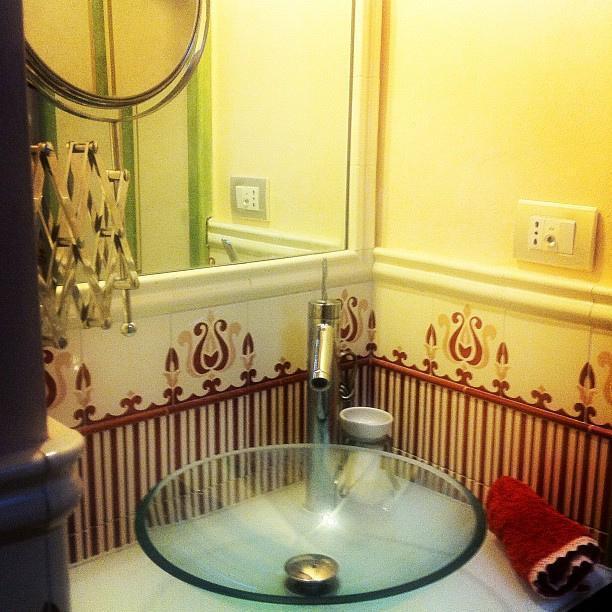How many people are in the photo?
Give a very brief answer. 0. 